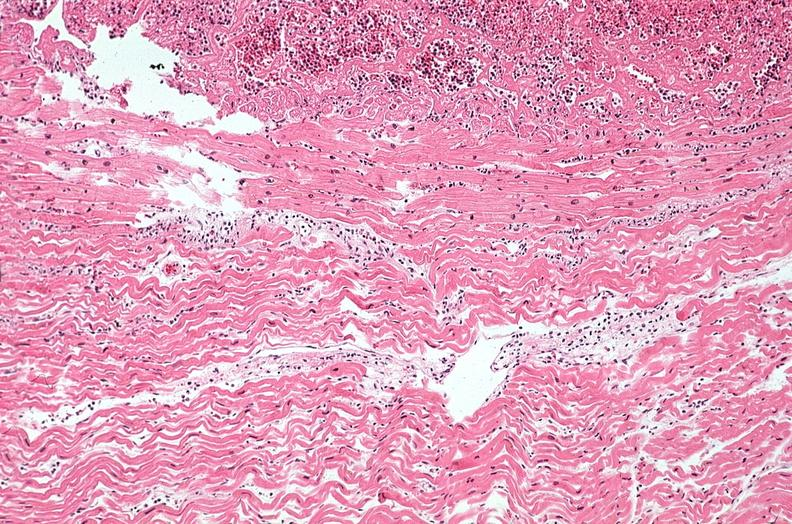does this image show heart, myocardial infarction, wavey fiber change, necrtosis, hemorrhage, and dissection?
Answer the question using a single word or phrase. Yes 